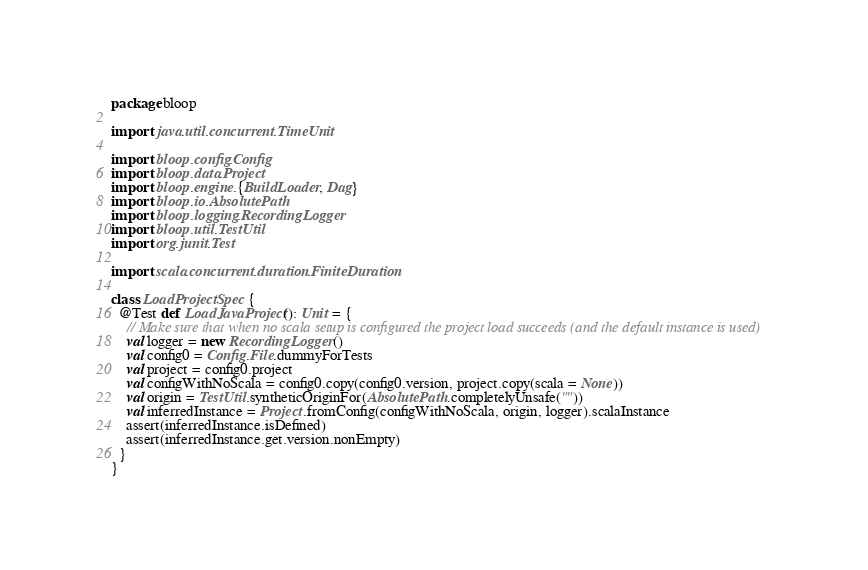<code> <loc_0><loc_0><loc_500><loc_500><_Scala_>package bloop

import java.util.concurrent.TimeUnit

import bloop.config.Config
import bloop.data.Project
import bloop.engine.{BuildLoader, Dag}
import bloop.io.AbsolutePath
import bloop.logging.RecordingLogger
import bloop.util.TestUtil
import org.junit.Test

import scala.concurrent.duration.FiniteDuration

class LoadProjectSpec {
  @Test def LoadJavaProject(): Unit = {
    // Make sure that when no scala setup is configured the project load succeeds (and the default instance is used)
    val logger = new RecordingLogger()
    val config0 = Config.File.dummyForTests
    val project = config0.project
    val configWithNoScala = config0.copy(config0.version, project.copy(scala = None))
    val origin = TestUtil.syntheticOriginFor(AbsolutePath.completelyUnsafe(""))
    val inferredInstance = Project.fromConfig(configWithNoScala, origin, logger).scalaInstance
    assert(inferredInstance.isDefined)
    assert(inferredInstance.get.version.nonEmpty)
  }
}
</code> 